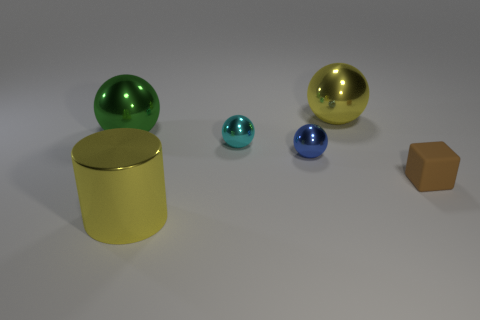Is the number of big things behind the small blue shiny ball less than the number of small purple metallic blocks?
Provide a succinct answer. No. There is a yellow thing in front of the tiny cyan metallic sphere; is its shape the same as the blue thing?
Give a very brief answer. No. Are there any other things that are the same color as the cylinder?
Ensure brevity in your answer.  Yes. There is a yellow cylinder that is the same material as the large green sphere; what size is it?
Your answer should be compact. Large. There is a yellow object behind the ball on the left side of the big shiny cylinder in front of the small brown thing; what is its material?
Make the answer very short. Metal. Are there fewer small metal spheres than large gray spheres?
Your response must be concise. No. Is the material of the small brown block the same as the cylinder?
Ensure brevity in your answer.  No. What is the shape of the large metal thing that is the same color as the cylinder?
Offer a terse response. Sphere. There is a ball to the left of the yellow shiny cylinder; does it have the same color as the shiny cylinder?
Provide a short and direct response. No. There is a big yellow object in front of the big green ball; how many large yellow metal cylinders are behind it?
Provide a short and direct response. 0. 